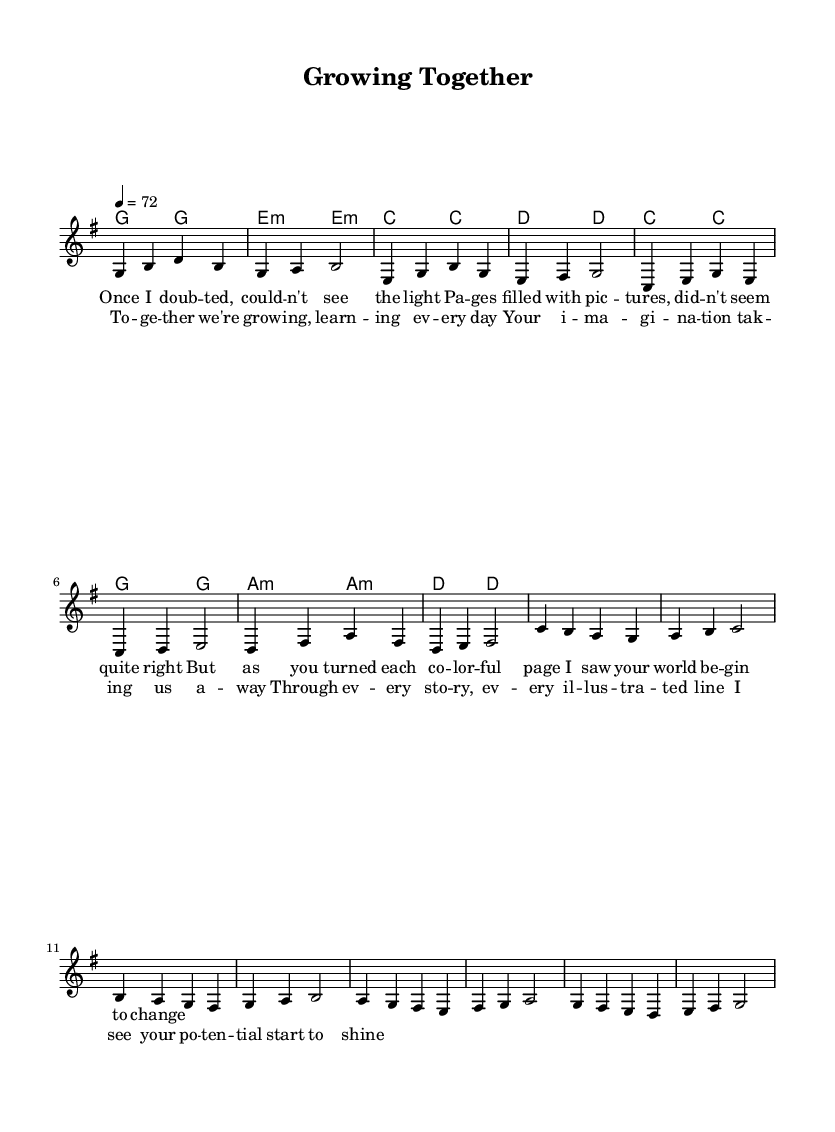What is the key signature of this piece? The key signature is G major, indicated by an F# on the staff.
Answer: G major What is the time signature indicated in the music? The time signature is 4/4, which means there are four beats in a measure.
Answer: 4/4 What is the tempo marking for this piece? The tempo marking indicates a speed of 72 beats per minute, which is described as moderato.
Answer: 72 How many measures are in the verse section? The verse section contains 8 measures, as counted from the beginning of the melody until the repeat.
Answer: 8 measures What is the first note of the chorus? The first note of the chorus is C, as shown in the melody line.
Answer: C Describe the relationship theme expressed in the lyrics. The lyrics describe a positive growth in the parent-child relationship through shared experiences and learning.
Answer: Growth in relationships How does the melody of the verse compare to that of the chorus? The verse melody generally moves stepwise and has a more reflective quality, while the chorus is more uplifting and reaches higher notes.
Answer: Reflective vs uplifting 